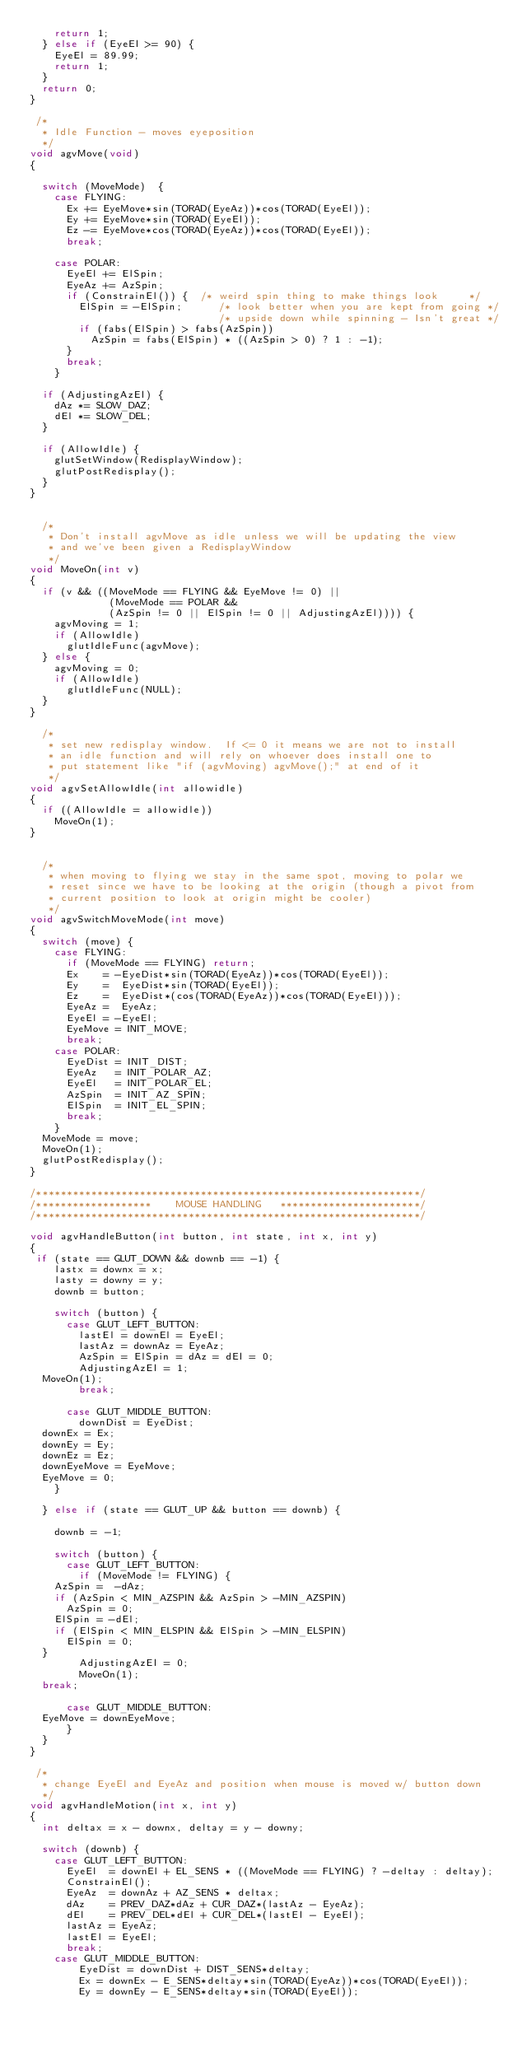Convert code to text. <code><loc_0><loc_0><loc_500><loc_500><_C_>    return 1;
  } else if (EyeEl >= 90) {
    EyeEl = 89.99;
    return 1;
  }
  return 0;
}

 /*
  * Idle Function - moves eyeposition
  */
void agvMove(void)
{

  switch (MoveMode)  {
    case FLYING:
      Ex += EyeMove*sin(TORAD(EyeAz))*cos(TORAD(EyeEl));
      Ey += EyeMove*sin(TORAD(EyeEl));
      Ez -= EyeMove*cos(TORAD(EyeAz))*cos(TORAD(EyeEl));
      break;

    case POLAR:
      EyeEl += ElSpin;
      EyeAz += AzSpin;
      if (ConstrainEl()) {  /* weird spin thing to make things look     */
        ElSpin = -ElSpin;      /* look better when you are kept from going */
                               /* upside down while spinning - Isn't great */
        if (fabs(ElSpin) > fabs(AzSpin))
          AzSpin = fabs(ElSpin) * ((AzSpin > 0) ? 1 : -1);
      }
      break;
    }

  if (AdjustingAzEl) {
    dAz *= SLOW_DAZ;
    dEl *= SLOW_DEL;
  }

  if (AllowIdle) {
    glutSetWindow(RedisplayWindow);
    glutPostRedisplay();
  }
}


  /*
   * Don't install agvMove as idle unless we will be updating the view
   * and we've been given a RedisplayWindow
   */
void MoveOn(int v)
{
  if (v && ((MoveMode == FLYING && EyeMove != 0) ||
             (MoveMode == POLAR &&
             (AzSpin != 0 || ElSpin != 0 || AdjustingAzEl)))) {
    agvMoving = 1;
    if (AllowIdle)
      glutIdleFunc(agvMove);
  } else {
    agvMoving = 0;
    if (AllowIdle)
      glutIdleFunc(NULL);
  }
}

  /*
   * set new redisplay window.  If <= 0 it means we are not to install
   * an idle function and will rely on whoever does install one to 
   * put statement like "if (agvMoving) agvMove();" at end of it
   */
void agvSetAllowIdle(int allowidle)
{
  if ((AllowIdle = allowidle))
    MoveOn(1);
}


  /*
   * when moving to flying we stay in the same spot, moving to polar we
   * reset since we have to be looking at the origin (though a pivot from
   * current position to look at origin might be cooler)
   */
void agvSwitchMoveMode(int move)
{
  switch (move) {
    case FLYING:
      if (MoveMode == FLYING) return;
      Ex    = -EyeDist*sin(TORAD(EyeAz))*cos(TORAD(EyeEl));
      Ey    =  EyeDist*sin(TORAD(EyeEl));
      Ez    =  EyeDist*(cos(TORAD(EyeAz))*cos(TORAD(EyeEl)));
      EyeAz =  EyeAz;
      EyeEl = -EyeEl;
      EyeMove = INIT_MOVE;
      break;
    case POLAR:
      EyeDist = INIT_DIST;
      EyeAz   = INIT_POLAR_AZ;
      EyeEl   = INIT_POLAR_EL;
      AzSpin  = INIT_AZ_SPIN;
      ElSpin  = INIT_EL_SPIN;
      break;
    }
  MoveMode = move;
  MoveOn(1);
  glutPostRedisplay();
}

/***************************************************************/
/*******************    MOUSE HANDLING   ***********************/
/***************************************************************/

void agvHandleButton(int button, int state, int x, int y)
{
 if (state == GLUT_DOWN && downb == -1) {  
    lastx = downx = x;
    lasty = downy = y;
    downb = button;    

    switch (button) {
      case GLUT_LEFT_BUTTON:
        lastEl = downEl = EyeEl;
        lastAz = downAz = EyeAz;
        AzSpin = ElSpin = dAz = dEl = 0;
        AdjustingAzEl = 1;
	MoveOn(1);
        break;

      case GLUT_MIDDLE_BUTTON:
        downDist = EyeDist;
	downEx = Ex;
	downEy = Ey;
	downEz = Ez;
	downEyeMove = EyeMove;
	EyeMove = 0;
    }

  } else if (state == GLUT_UP && button == downb) {

    downb = -1;

    switch (button) {
      case GLUT_LEFT_BUTTON:
        if (MoveMode != FLYING) {
	  AzSpin =  -dAz;
	  if (AzSpin < MIN_AZSPIN && AzSpin > -MIN_AZSPIN)
	    AzSpin = 0;	
	  ElSpin = -dEl;
	  if (ElSpin < MIN_ELSPIN && ElSpin > -MIN_ELSPIN)
	    ElSpin = 0; 
	}
        AdjustingAzEl = 0;
        MoveOn(1);
	break;

      case GLUT_MIDDLE_BUTTON:
	EyeMove = downEyeMove;
      }
  }
}

 /*
  * change EyeEl and EyeAz and position when mouse is moved w/ button down
  */
void agvHandleMotion(int x, int y)
{
  int deltax = x - downx, deltay = y - downy;

  switch (downb) {
    case GLUT_LEFT_BUTTON:
      EyeEl  = downEl + EL_SENS * ((MoveMode == FLYING) ? -deltay : deltay);
      ConstrainEl();
      EyeAz  = downAz + AZ_SENS * deltax;
      dAz    = PREV_DAZ*dAz + CUR_DAZ*(lastAz - EyeAz);
      dEl    = PREV_DEL*dEl + CUR_DEL*(lastEl - EyeEl);
      lastAz = EyeAz;
      lastEl = EyeEl;
      break;
    case GLUT_MIDDLE_BUTTON:
        EyeDist = downDist + DIST_SENS*deltay;
        Ex = downEx - E_SENS*deltay*sin(TORAD(EyeAz))*cos(TORAD(EyeEl));
        Ey = downEy - E_SENS*deltay*sin(TORAD(EyeEl));</code> 